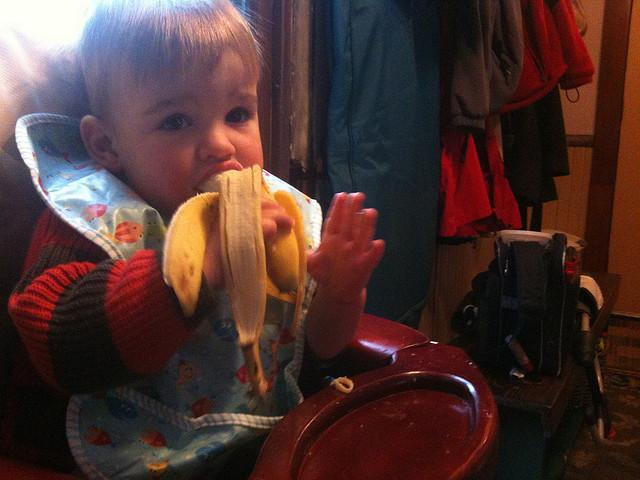Why is he wearing a bib? Please explain your reasoning. protect clothing. Due to a lack of mature coordination skills and an underdeveloped motor control ability, this young child is very likely to get messy when eating food so his bib is being obviously employed as a means of protecting his clothing from stains and spills. 